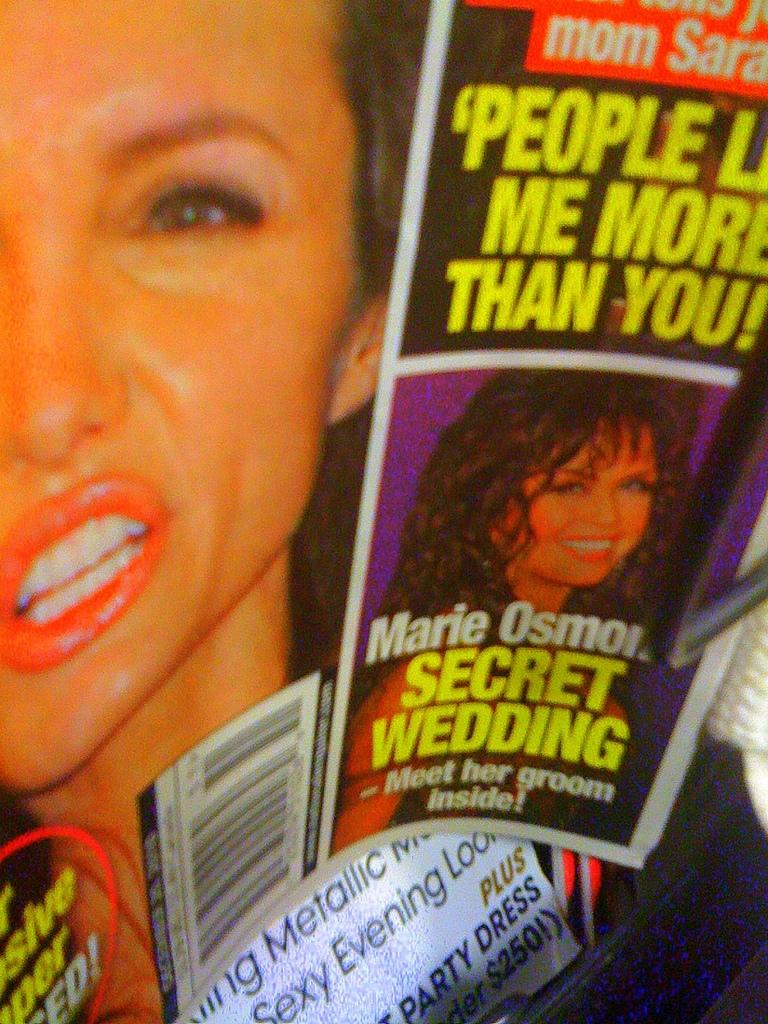<image>
Present a compact description of the photo's key features. A picture of a tabloid magazine that reads Marie Osmond SECRET WEDDING. 